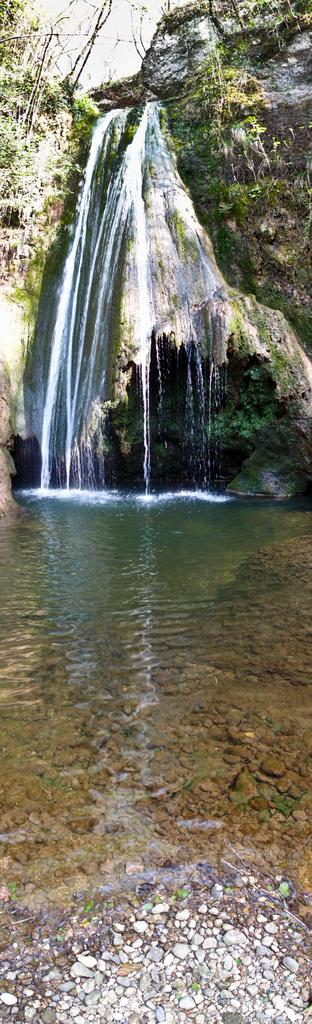What is visible at the bottom of the image? Water is visible at the bottom of the image, and small stones are present in the water. What is happening in the background of the image? Water is falling from rocks in the background, and there are trees and the sky visible. What type of sea creature can be seen swimming in the water at the bottom of the image? There are no sea creatures visible in the image; it features water and small stones at the bottom. What is the position of the spring in the image? There is no spring present in the image. 